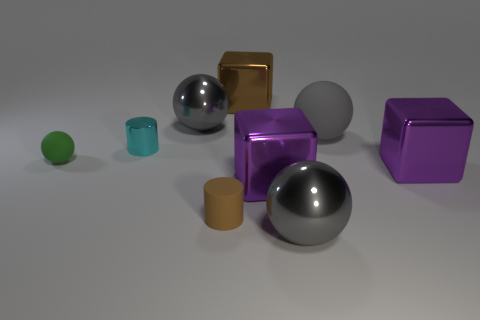There is a thing that is the same color as the matte cylinder; what is its shape?
Offer a very short reply. Cube. Are there an equal number of small green balls in front of the metal cylinder and brown metallic blocks?
Ensure brevity in your answer.  Yes. What is the color of the other large matte object that is the same shape as the green matte object?
Ensure brevity in your answer.  Gray. Are the small thing that is behind the green object and the small green ball made of the same material?
Your response must be concise. No. How many small things are either green rubber spheres or brown metal cubes?
Your answer should be compact. 1. The cyan shiny object has what size?
Your response must be concise. Small. Does the rubber cylinder have the same size as the gray metallic sphere in front of the tiny shiny thing?
Give a very brief answer. No. How many yellow objects are either matte cylinders or tiny cylinders?
Give a very brief answer. 0. How many purple shiny blocks are there?
Keep it short and to the point. 2. There is a gray thing left of the matte cylinder; how big is it?
Keep it short and to the point. Large. 